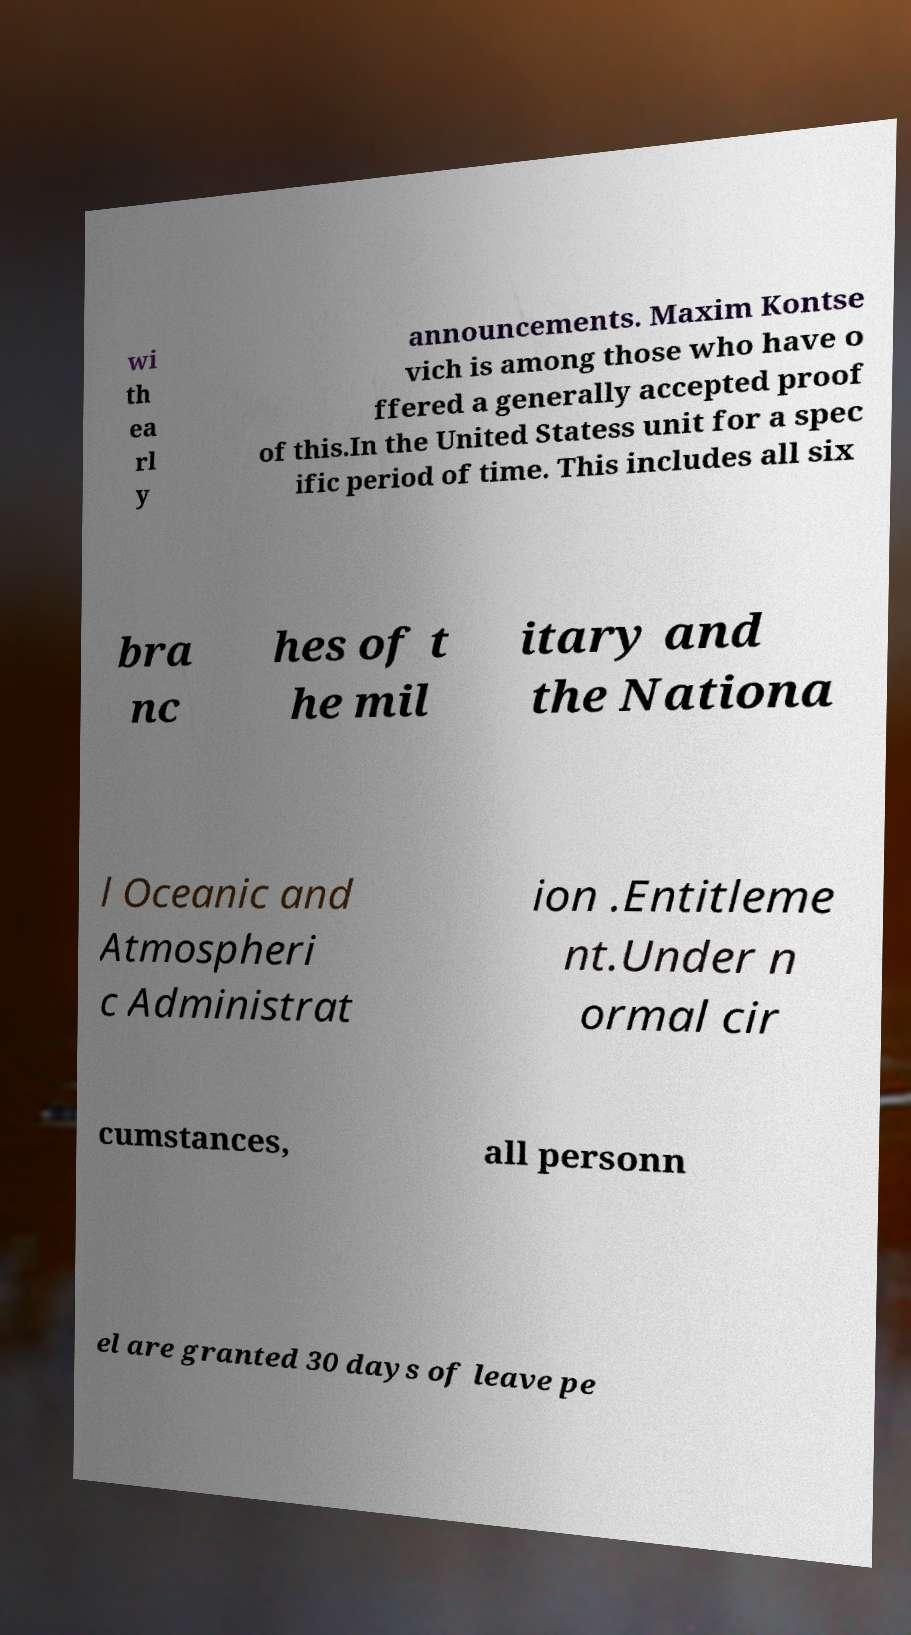What messages or text are displayed in this image? I need them in a readable, typed format. wi th ea rl y announcements. Maxim Kontse vich is among those who have o ffered a generally accepted proof of this.In the United Statess unit for a spec ific period of time. This includes all six bra nc hes of t he mil itary and the Nationa l Oceanic and Atmospheri c Administrat ion .Entitleme nt.Under n ormal cir cumstances, all personn el are granted 30 days of leave pe 